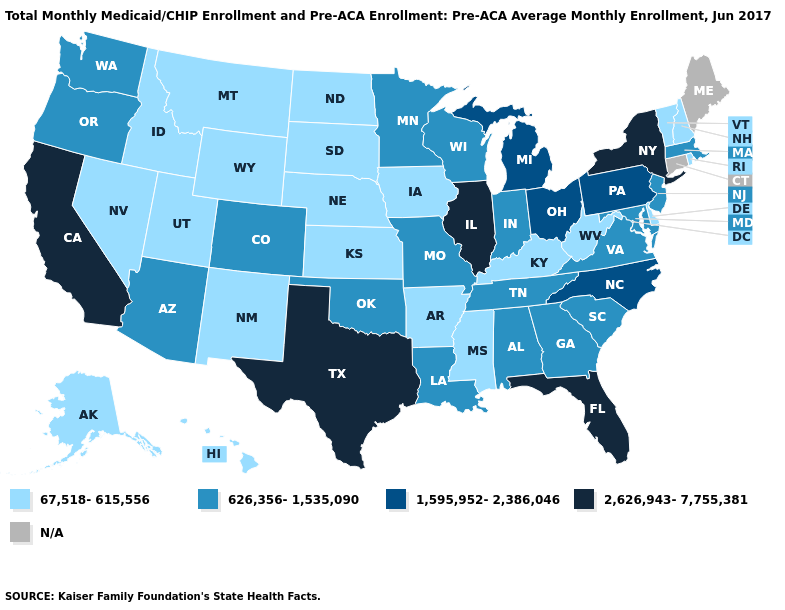Does the first symbol in the legend represent the smallest category?
Answer briefly. Yes. What is the lowest value in the West?
Write a very short answer. 67,518-615,556. What is the highest value in states that border Missouri?
Give a very brief answer. 2,626,943-7,755,381. What is the value of Maine?
Keep it brief. N/A. Name the states that have a value in the range 2,626,943-7,755,381?
Short answer required. California, Florida, Illinois, New York, Texas. Does Florida have the highest value in the South?
Quick response, please. Yes. How many symbols are there in the legend?
Answer briefly. 5. Name the states that have a value in the range 626,356-1,535,090?
Concise answer only. Alabama, Arizona, Colorado, Georgia, Indiana, Louisiana, Maryland, Massachusetts, Minnesota, Missouri, New Jersey, Oklahoma, Oregon, South Carolina, Tennessee, Virginia, Washington, Wisconsin. What is the value of New Mexico?
Short answer required. 67,518-615,556. What is the value of New Jersey?
Keep it brief. 626,356-1,535,090. What is the value of Oregon?
Quick response, please. 626,356-1,535,090. Name the states that have a value in the range 1,595,952-2,386,046?
Quick response, please. Michigan, North Carolina, Ohio, Pennsylvania. Name the states that have a value in the range 67,518-615,556?
Keep it brief. Alaska, Arkansas, Delaware, Hawaii, Idaho, Iowa, Kansas, Kentucky, Mississippi, Montana, Nebraska, Nevada, New Hampshire, New Mexico, North Dakota, Rhode Island, South Dakota, Utah, Vermont, West Virginia, Wyoming. 